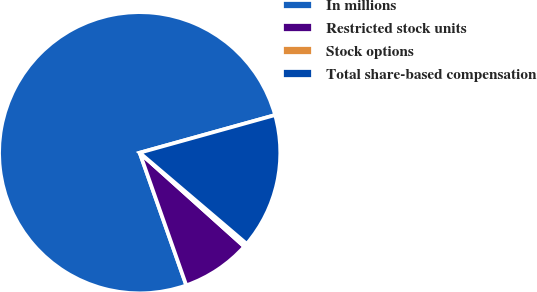Convert chart. <chart><loc_0><loc_0><loc_500><loc_500><pie_chart><fcel>In millions<fcel>Restricted stock units<fcel>Stock options<fcel>Total share-based compensation<nl><fcel>76.06%<fcel>7.98%<fcel>0.42%<fcel>15.54%<nl></chart> 